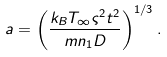Convert formula to latex. <formula><loc_0><loc_0><loc_500><loc_500>a = \left ( \frac { k _ { B } T _ { \infty } \varsigma ^ { 2 } t ^ { 2 } } { m n _ { 1 } D } \right ) ^ { 1 / 3 } .</formula> 